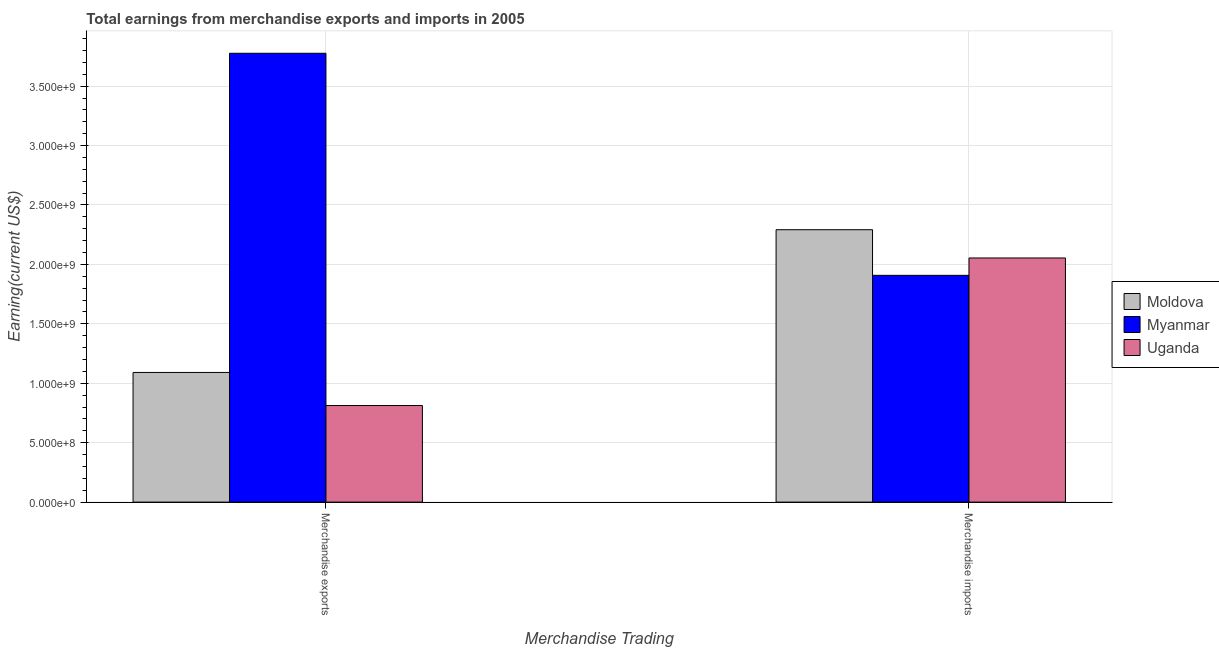Are the number of bars per tick equal to the number of legend labels?
Your answer should be compact. Yes. How many bars are there on the 2nd tick from the left?
Ensure brevity in your answer.  3. What is the label of the 2nd group of bars from the left?
Your answer should be very brief. Merchandise imports. What is the earnings from merchandise exports in Uganda?
Ensure brevity in your answer.  8.13e+08. Across all countries, what is the maximum earnings from merchandise exports?
Ensure brevity in your answer.  3.78e+09. Across all countries, what is the minimum earnings from merchandise imports?
Keep it short and to the point. 1.91e+09. In which country was the earnings from merchandise imports maximum?
Give a very brief answer. Moldova. In which country was the earnings from merchandise imports minimum?
Make the answer very short. Myanmar. What is the total earnings from merchandise imports in the graph?
Ensure brevity in your answer.  6.25e+09. What is the difference between the earnings from merchandise exports in Myanmar and that in Moldova?
Provide a succinct answer. 2.69e+09. What is the difference between the earnings from merchandise exports in Moldova and the earnings from merchandise imports in Myanmar?
Provide a succinct answer. -8.17e+08. What is the average earnings from merchandise exports per country?
Ensure brevity in your answer.  1.89e+09. What is the difference between the earnings from merchandise exports and earnings from merchandise imports in Myanmar?
Give a very brief answer. 1.87e+09. In how many countries, is the earnings from merchandise exports greater than 3100000000 US$?
Provide a short and direct response. 1. What is the ratio of the earnings from merchandise exports in Myanmar to that in Moldova?
Provide a short and direct response. 3.46. Is the earnings from merchandise imports in Uganda less than that in Moldova?
Keep it short and to the point. Yes. What does the 2nd bar from the left in Merchandise exports represents?
Your answer should be compact. Myanmar. What does the 1st bar from the right in Merchandise exports represents?
Offer a very short reply. Uganda. How many bars are there?
Your response must be concise. 6. Are all the bars in the graph horizontal?
Your answer should be compact. No. How many countries are there in the graph?
Give a very brief answer. 3. Does the graph contain any zero values?
Give a very brief answer. No. Does the graph contain grids?
Keep it short and to the point. Yes. Where does the legend appear in the graph?
Keep it short and to the point. Center right. What is the title of the graph?
Keep it short and to the point. Total earnings from merchandise exports and imports in 2005. Does "Euro area" appear as one of the legend labels in the graph?
Your answer should be very brief. No. What is the label or title of the X-axis?
Provide a succinct answer. Merchandise Trading. What is the label or title of the Y-axis?
Your answer should be very brief. Earning(current US$). What is the Earning(current US$) of Moldova in Merchandise exports?
Provide a short and direct response. 1.09e+09. What is the Earning(current US$) in Myanmar in Merchandise exports?
Provide a succinct answer. 3.78e+09. What is the Earning(current US$) of Uganda in Merchandise exports?
Your response must be concise. 8.13e+08. What is the Earning(current US$) of Moldova in Merchandise imports?
Offer a very short reply. 2.29e+09. What is the Earning(current US$) of Myanmar in Merchandise imports?
Offer a very short reply. 1.91e+09. What is the Earning(current US$) in Uganda in Merchandise imports?
Your answer should be very brief. 2.05e+09. Across all Merchandise Trading, what is the maximum Earning(current US$) in Moldova?
Your answer should be very brief. 2.29e+09. Across all Merchandise Trading, what is the maximum Earning(current US$) of Myanmar?
Ensure brevity in your answer.  3.78e+09. Across all Merchandise Trading, what is the maximum Earning(current US$) in Uganda?
Provide a short and direct response. 2.05e+09. Across all Merchandise Trading, what is the minimum Earning(current US$) in Moldova?
Offer a very short reply. 1.09e+09. Across all Merchandise Trading, what is the minimum Earning(current US$) in Myanmar?
Offer a very short reply. 1.91e+09. Across all Merchandise Trading, what is the minimum Earning(current US$) of Uganda?
Offer a very short reply. 8.13e+08. What is the total Earning(current US$) in Moldova in the graph?
Your answer should be compact. 3.38e+09. What is the total Earning(current US$) of Myanmar in the graph?
Ensure brevity in your answer.  5.68e+09. What is the total Earning(current US$) of Uganda in the graph?
Your answer should be compact. 2.87e+09. What is the difference between the Earning(current US$) in Moldova in Merchandise exports and that in Merchandise imports?
Provide a short and direct response. -1.20e+09. What is the difference between the Earning(current US$) in Myanmar in Merchandise exports and that in Merchandise imports?
Your answer should be very brief. 1.87e+09. What is the difference between the Earning(current US$) of Uganda in Merchandise exports and that in Merchandise imports?
Keep it short and to the point. -1.24e+09. What is the difference between the Earning(current US$) of Moldova in Merchandise exports and the Earning(current US$) of Myanmar in Merchandise imports?
Your answer should be compact. -8.17e+08. What is the difference between the Earning(current US$) in Moldova in Merchandise exports and the Earning(current US$) in Uganda in Merchandise imports?
Offer a very short reply. -9.63e+08. What is the difference between the Earning(current US$) of Myanmar in Merchandise exports and the Earning(current US$) of Uganda in Merchandise imports?
Offer a very short reply. 1.72e+09. What is the average Earning(current US$) of Moldova per Merchandise Trading?
Offer a very short reply. 1.69e+09. What is the average Earning(current US$) of Myanmar per Merchandise Trading?
Give a very brief answer. 2.84e+09. What is the average Earning(current US$) of Uganda per Merchandise Trading?
Your response must be concise. 1.43e+09. What is the difference between the Earning(current US$) in Moldova and Earning(current US$) in Myanmar in Merchandise exports?
Ensure brevity in your answer.  -2.69e+09. What is the difference between the Earning(current US$) of Moldova and Earning(current US$) of Uganda in Merchandise exports?
Ensure brevity in your answer.  2.78e+08. What is the difference between the Earning(current US$) in Myanmar and Earning(current US$) in Uganda in Merchandise exports?
Your answer should be compact. 2.96e+09. What is the difference between the Earning(current US$) of Moldova and Earning(current US$) of Myanmar in Merchandise imports?
Offer a very short reply. 3.84e+08. What is the difference between the Earning(current US$) in Moldova and Earning(current US$) in Uganda in Merchandise imports?
Provide a short and direct response. 2.38e+08. What is the difference between the Earning(current US$) of Myanmar and Earning(current US$) of Uganda in Merchandise imports?
Your answer should be compact. -1.46e+08. What is the ratio of the Earning(current US$) in Moldova in Merchandise exports to that in Merchandise imports?
Your answer should be compact. 0.48. What is the ratio of the Earning(current US$) in Myanmar in Merchandise exports to that in Merchandise imports?
Ensure brevity in your answer.  1.98. What is the ratio of the Earning(current US$) in Uganda in Merchandise exports to that in Merchandise imports?
Ensure brevity in your answer.  0.4. What is the difference between the highest and the second highest Earning(current US$) of Moldova?
Keep it short and to the point. 1.20e+09. What is the difference between the highest and the second highest Earning(current US$) of Myanmar?
Keep it short and to the point. 1.87e+09. What is the difference between the highest and the second highest Earning(current US$) of Uganda?
Provide a succinct answer. 1.24e+09. What is the difference between the highest and the lowest Earning(current US$) in Moldova?
Your response must be concise. 1.20e+09. What is the difference between the highest and the lowest Earning(current US$) of Myanmar?
Your response must be concise. 1.87e+09. What is the difference between the highest and the lowest Earning(current US$) in Uganda?
Offer a terse response. 1.24e+09. 